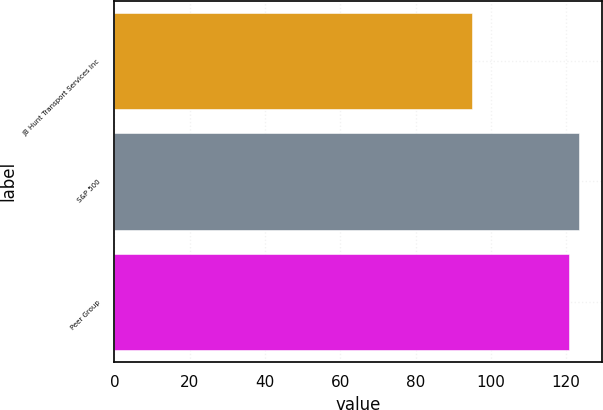Convert chart. <chart><loc_0><loc_0><loc_500><loc_500><bar_chart><fcel>JB Hunt Transport Services Inc<fcel>S&P 500<fcel>Peer Group<nl><fcel>95.07<fcel>123.4<fcel>120.76<nl></chart> 